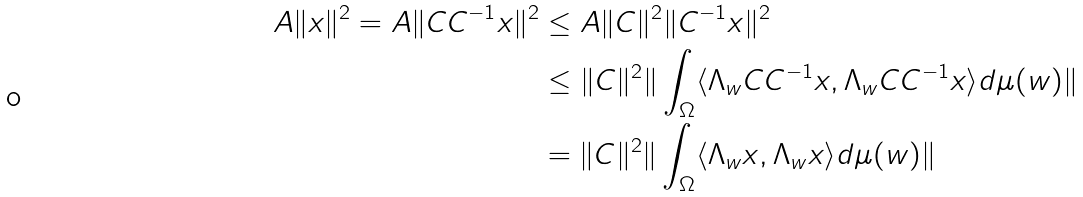<formula> <loc_0><loc_0><loc_500><loc_500>A \| x \| ^ { 2 } = A \| C C ^ { - 1 } x \| ^ { 2 } & \leq A \| C \| ^ { 2 } \| C ^ { - 1 } x \| ^ { 2 } \\ & \leq \| C \| ^ { 2 } \| \int _ { \Omega } \langle \Lambda _ { w } C C ^ { - 1 } x , \Lambda _ { w } C C ^ { - 1 } x \rangle d \mu ( w ) \| \\ & = \| C \| ^ { 2 } \| \int _ { \Omega } \langle \Lambda _ { w } x , \Lambda _ { w } x \rangle d \mu ( w ) \| \\</formula> 